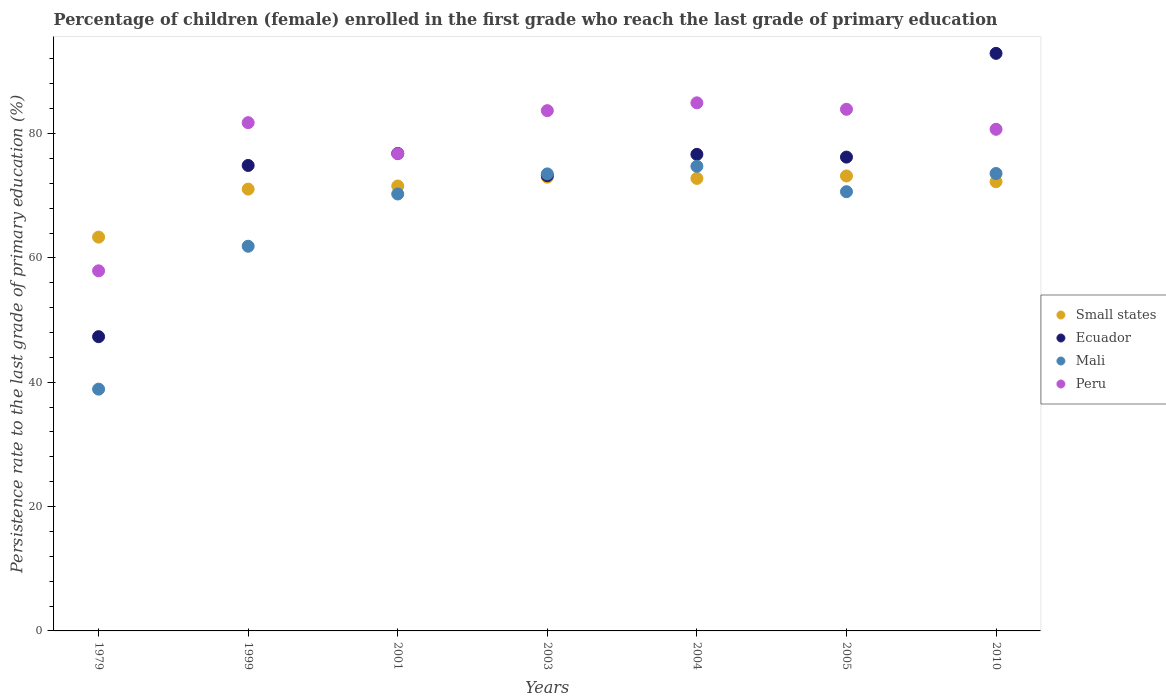Is the number of dotlines equal to the number of legend labels?
Keep it short and to the point. Yes. What is the persistence rate of children in Ecuador in 2003?
Your answer should be very brief. 73.23. Across all years, what is the maximum persistence rate of children in Ecuador?
Your response must be concise. 92.9. Across all years, what is the minimum persistence rate of children in Small states?
Give a very brief answer. 63.34. In which year was the persistence rate of children in Peru maximum?
Provide a short and direct response. 2004. In which year was the persistence rate of children in Ecuador minimum?
Your response must be concise. 1979. What is the total persistence rate of children in Mali in the graph?
Ensure brevity in your answer.  463.53. What is the difference between the persistence rate of children in Ecuador in 1979 and that in 2003?
Keep it short and to the point. -25.9. What is the difference between the persistence rate of children in Small states in 2003 and the persistence rate of children in Mali in 2010?
Offer a very short reply. -0.59. What is the average persistence rate of children in Mali per year?
Offer a very short reply. 66.22. In the year 2001, what is the difference between the persistence rate of children in Peru and persistence rate of children in Mali?
Provide a short and direct response. 6.48. What is the ratio of the persistence rate of children in Mali in 1999 to that in 2010?
Offer a terse response. 0.84. Is the persistence rate of children in Small states in 1979 less than that in 2004?
Keep it short and to the point. Yes. Is the difference between the persistence rate of children in Peru in 1979 and 2004 greater than the difference between the persistence rate of children in Mali in 1979 and 2004?
Your answer should be very brief. Yes. What is the difference between the highest and the second highest persistence rate of children in Mali?
Your response must be concise. 1.16. What is the difference between the highest and the lowest persistence rate of children in Ecuador?
Provide a short and direct response. 45.57. In how many years, is the persistence rate of children in Small states greater than the average persistence rate of children in Small states taken over all years?
Provide a succinct answer. 6. Is the sum of the persistence rate of children in Ecuador in 1999 and 2004 greater than the maximum persistence rate of children in Small states across all years?
Offer a very short reply. Yes. Is it the case that in every year, the sum of the persistence rate of children in Peru and persistence rate of children in Small states  is greater than the persistence rate of children in Mali?
Provide a short and direct response. Yes. Does the persistence rate of children in Small states monotonically increase over the years?
Keep it short and to the point. No. How many years are there in the graph?
Your answer should be compact. 7. What is the difference between two consecutive major ticks on the Y-axis?
Your response must be concise. 20. Does the graph contain any zero values?
Keep it short and to the point. No. Where does the legend appear in the graph?
Provide a succinct answer. Center right. How are the legend labels stacked?
Your answer should be compact. Vertical. What is the title of the graph?
Make the answer very short. Percentage of children (female) enrolled in the first grade who reach the last grade of primary education. Does "United Arab Emirates" appear as one of the legend labels in the graph?
Make the answer very short. No. What is the label or title of the X-axis?
Your answer should be compact. Years. What is the label or title of the Y-axis?
Offer a terse response. Persistence rate to the last grade of primary education (%). What is the Persistence rate to the last grade of primary education (%) of Small states in 1979?
Provide a short and direct response. 63.34. What is the Persistence rate to the last grade of primary education (%) in Ecuador in 1979?
Ensure brevity in your answer.  47.33. What is the Persistence rate to the last grade of primary education (%) in Mali in 1979?
Offer a very short reply. 38.89. What is the Persistence rate to the last grade of primary education (%) in Peru in 1979?
Make the answer very short. 57.92. What is the Persistence rate to the last grade of primary education (%) of Small states in 1999?
Make the answer very short. 71.07. What is the Persistence rate to the last grade of primary education (%) in Ecuador in 1999?
Ensure brevity in your answer.  74.87. What is the Persistence rate to the last grade of primary education (%) in Mali in 1999?
Provide a succinct answer. 61.88. What is the Persistence rate to the last grade of primary education (%) of Peru in 1999?
Your answer should be very brief. 81.75. What is the Persistence rate to the last grade of primary education (%) of Small states in 2001?
Keep it short and to the point. 71.57. What is the Persistence rate to the last grade of primary education (%) in Ecuador in 2001?
Give a very brief answer. 76.8. What is the Persistence rate to the last grade of primary education (%) of Mali in 2001?
Keep it short and to the point. 70.28. What is the Persistence rate to the last grade of primary education (%) in Peru in 2001?
Your answer should be compact. 76.77. What is the Persistence rate to the last grade of primary education (%) of Small states in 2003?
Make the answer very short. 72.99. What is the Persistence rate to the last grade of primary education (%) in Ecuador in 2003?
Offer a very short reply. 73.23. What is the Persistence rate to the last grade of primary education (%) of Mali in 2003?
Offer a very short reply. 73.51. What is the Persistence rate to the last grade of primary education (%) in Peru in 2003?
Ensure brevity in your answer.  83.69. What is the Persistence rate to the last grade of primary education (%) in Small states in 2004?
Give a very brief answer. 72.79. What is the Persistence rate to the last grade of primary education (%) of Ecuador in 2004?
Keep it short and to the point. 76.66. What is the Persistence rate to the last grade of primary education (%) in Mali in 2004?
Provide a succinct answer. 74.74. What is the Persistence rate to the last grade of primary education (%) in Peru in 2004?
Provide a short and direct response. 84.95. What is the Persistence rate to the last grade of primary education (%) in Small states in 2005?
Your response must be concise. 73.18. What is the Persistence rate to the last grade of primary education (%) of Ecuador in 2005?
Your answer should be very brief. 76.22. What is the Persistence rate to the last grade of primary education (%) of Mali in 2005?
Your answer should be compact. 70.65. What is the Persistence rate to the last grade of primary education (%) in Peru in 2005?
Make the answer very short. 83.91. What is the Persistence rate to the last grade of primary education (%) in Small states in 2010?
Provide a succinct answer. 72.26. What is the Persistence rate to the last grade of primary education (%) in Ecuador in 2010?
Make the answer very short. 92.9. What is the Persistence rate to the last grade of primary education (%) in Mali in 2010?
Provide a short and direct response. 73.58. What is the Persistence rate to the last grade of primary education (%) of Peru in 2010?
Keep it short and to the point. 80.69. Across all years, what is the maximum Persistence rate to the last grade of primary education (%) of Small states?
Keep it short and to the point. 73.18. Across all years, what is the maximum Persistence rate to the last grade of primary education (%) in Ecuador?
Ensure brevity in your answer.  92.9. Across all years, what is the maximum Persistence rate to the last grade of primary education (%) of Mali?
Your answer should be very brief. 74.74. Across all years, what is the maximum Persistence rate to the last grade of primary education (%) in Peru?
Provide a short and direct response. 84.95. Across all years, what is the minimum Persistence rate to the last grade of primary education (%) in Small states?
Ensure brevity in your answer.  63.34. Across all years, what is the minimum Persistence rate to the last grade of primary education (%) of Ecuador?
Your answer should be very brief. 47.33. Across all years, what is the minimum Persistence rate to the last grade of primary education (%) of Mali?
Make the answer very short. 38.89. Across all years, what is the minimum Persistence rate to the last grade of primary education (%) in Peru?
Your answer should be very brief. 57.92. What is the total Persistence rate to the last grade of primary education (%) in Small states in the graph?
Offer a terse response. 497.2. What is the total Persistence rate to the last grade of primary education (%) of Ecuador in the graph?
Offer a terse response. 518.01. What is the total Persistence rate to the last grade of primary education (%) in Mali in the graph?
Offer a terse response. 463.53. What is the total Persistence rate to the last grade of primary education (%) in Peru in the graph?
Make the answer very short. 549.67. What is the difference between the Persistence rate to the last grade of primary education (%) of Small states in 1979 and that in 1999?
Make the answer very short. -7.73. What is the difference between the Persistence rate to the last grade of primary education (%) in Ecuador in 1979 and that in 1999?
Ensure brevity in your answer.  -27.54. What is the difference between the Persistence rate to the last grade of primary education (%) of Mali in 1979 and that in 1999?
Your response must be concise. -22.99. What is the difference between the Persistence rate to the last grade of primary education (%) in Peru in 1979 and that in 1999?
Provide a short and direct response. -23.83. What is the difference between the Persistence rate to the last grade of primary education (%) in Small states in 1979 and that in 2001?
Offer a very short reply. -8.22. What is the difference between the Persistence rate to the last grade of primary education (%) in Ecuador in 1979 and that in 2001?
Offer a terse response. -29.47. What is the difference between the Persistence rate to the last grade of primary education (%) of Mali in 1979 and that in 2001?
Offer a very short reply. -31.39. What is the difference between the Persistence rate to the last grade of primary education (%) in Peru in 1979 and that in 2001?
Provide a short and direct response. -18.84. What is the difference between the Persistence rate to the last grade of primary education (%) in Small states in 1979 and that in 2003?
Offer a terse response. -9.64. What is the difference between the Persistence rate to the last grade of primary education (%) of Ecuador in 1979 and that in 2003?
Make the answer very short. -25.9. What is the difference between the Persistence rate to the last grade of primary education (%) of Mali in 1979 and that in 2003?
Ensure brevity in your answer.  -34.62. What is the difference between the Persistence rate to the last grade of primary education (%) in Peru in 1979 and that in 2003?
Give a very brief answer. -25.76. What is the difference between the Persistence rate to the last grade of primary education (%) in Small states in 1979 and that in 2004?
Provide a succinct answer. -9.44. What is the difference between the Persistence rate to the last grade of primary education (%) of Ecuador in 1979 and that in 2004?
Offer a terse response. -29.33. What is the difference between the Persistence rate to the last grade of primary education (%) of Mali in 1979 and that in 2004?
Your answer should be very brief. -35.85. What is the difference between the Persistence rate to the last grade of primary education (%) in Peru in 1979 and that in 2004?
Make the answer very short. -27.02. What is the difference between the Persistence rate to the last grade of primary education (%) of Small states in 1979 and that in 2005?
Provide a succinct answer. -9.84. What is the difference between the Persistence rate to the last grade of primary education (%) of Ecuador in 1979 and that in 2005?
Ensure brevity in your answer.  -28.88. What is the difference between the Persistence rate to the last grade of primary education (%) in Mali in 1979 and that in 2005?
Your response must be concise. -31.76. What is the difference between the Persistence rate to the last grade of primary education (%) in Peru in 1979 and that in 2005?
Your response must be concise. -25.98. What is the difference between the Persistence rate to the last grade of primary education (%) in Small states in 1979 and that in 2010?
Provide a short and direct response. -8.92. What is the difference between the Persistence rate to the last grade of primary education (%) of Ecuador in 1979 and that in 2010?
Give a very brief answer. -45.57. What is the difference between the Persistence rate to the last grade of primary education (%) in Mali in 1979 and that in 2010?
Your answer should be compact. -34.69. What is the difference between the Persistence rate to the last grade of primary education (%) in Peru in 1979 and that in 2010?
Your answer should be compact. -22.76. What is the difference between the Persistence rate to the last grade of primary education (%) in Small states in 1999 and that in 2001?
Provide a short and direct response. -0.5. What is the difference between the Persistence rate to the last grade of primary education (%) of Ecuador in 1999 and that in 2001?
Keep it short and to the point. -1.93. What is the difference between the Persistence rate to the last grade of primary education (%) of Mali in 1999 and that in 2001?
Make the answer very short. -8.41. What is the difference between the Persistence rate to the last grade of primary education (%) in Peru in 1999 and that in 2001?
Your answer should be compact. 4.99. What is the difference between the Persistence rate to the last grade of primary education (%) in Small states in 1999 and that in 2003?
Your answer should be very brief. -1.92. What is the difference between the Persistence rate to the last grade of primary education (%) of Ecuador in 1999 and that in 2003?
Provide a short and direct response. 1.64. What is the difference between the Persistence rate to the last grade of primary education (%) of Mali in 1999 and that in 2003?
Your response must be concise. -11.64. What is the difference between the Persistence rate to the last grade of primary education (%) in Peru in 1999 and that in 2003?
Your answer should be compact. -1.93. What is the difference between the Persistence rate to the last grade of primary education (%) of Small states in 1999 and that in 2004?
Provide a short and direct response. -1.72. What is the difference between the Persistence rate to the last grade of primary education (%) of Ecuador in 1999 and that in 2004?
Keep it short and to the point. -1.79. What is the difference between the Persistence rate to the last grade of primary education (%) of Mali in 1999 and that in 2004?
Provide a short and direct response. -12.86. What is the difference between the Persistence rate to the last grade of primary education (%) of Peru in 1999 and that in 2004?
Offer a terse response. -3.19. What is the difference between the Persistence rate to the last grade of primary education (%) of Small states in 1999 and that in 2005?
Give a very brief answer. -2.11. What is the difference between the Persistence rate to the last grade of primary education (%) of Ecuador in 1999 and that in 2005?
Offer a terse response. -1.34. What is the difference between the Persistence rate to the last grade of primary education (%) in Mali in 1999 and that in 2005?
Ensure brevity in your answer.  -8.77. What is the difference between the Persistence rate to the last grade of primary education (%) of Peru in 1999 and that in 2005?
Your answer should be very brief. -2.15. What is the difference between the Persistence rate to the last grade of primary education (%) of Small states in 1999 and that in 2010?
Offer a very short reply. -1.19. What is the difference between the Persistence rate to the last grade of primary education (%) of Ecuador in 1999 and that in 2010?
Your answer should be very brief. -18.03. What is the difference between the Persistence rate to the last grade of primary education (%) of Mali in 1999 and that in 2010?
Provide a succinct answer. -11.7. What is the difference between the Persistence rate to the last grade of primary education (%) of Peru in 1999 and that in 2010?
Make the answer very short. 1.07. What is the difference between the Persistence rate to the last grade of primary education (%) of Small states in 2001 and that in 2003?
Make the answer very short. -1.42. What is the difference between the Persistence rate to the last grade of primary education (%) of Ecuador in 2001 and that in 2003?
Provide a short and direct response. 3.57. What is the difference between the Persistence rate to the last grade of primary education (%) of Mali in 2001 and that in 2003?
Your answer should be compact. -3.23. What is the difference between the Persistence rate to the last grade of primary education (%) in Peru in 2001 and that in 2003?
Provide a short and direct response. -6.92. What is the difference between the Persistence rate to the last grade of primary education (%) of Small states in 2001 and that in 2004?
Keep it short and to the point. -1.22. What is the difference between the Persistence rate to the last grade of primary education (%) of Ecuador in 2001 and that in 2004?
Your answer should be compact. 0.15. What is the difference between the Persistence rate to the last grade of primary education (%) in Mali in 2001 and that in 2004?
Your answer should be very brief. -4.46. What is the difference between the Persistence rate to the last grade of primary education (%) in Peru in 2001 and that in 2004?
Make the answer very short. -8.18. What is the difference between the Persistence rate to the last grade of primary education (%) in Small states in 2001 and that in 2005?
Offer a very short reply. -1.62. What is the difference between the Persistence rate to the last grade of primary education (%) of Ecuador in 2001 and that in 2005?
Offer a very short reply. 0.59. What is the difference between the Persistence rate to the last grade of primary education (%) of Mali in 2001 and that in 2005?
Provide a succinct answer. -0.37. What is the difference between the Persistence rate to the last grade of primary education (%) of Peru in 2001 and that in 2005?
Ensure brevity in your answer.  -7.14. What is the difference between the Persistence rate to the last grade of primary education (%) of Small states in 2001 and that in 2010?
Provide a short and direct response. -0.7. What is the difference between the Persistence rate to the last grade of primary education (%) in Ecuador in 2001 and that in 2010?
Make the answer very short. -16.1. What is the difference between the Persistence rate to the last grade of primary education (%) in Mali in 2001 and that in 2010?
Offer a terse response. -3.3. What is the difference between the Persistence rate to the last grade of primary education (%) of Peru in 2001 and that in 2010?
Make the answer very short. -3.92. What is the difference between the Persistence rate to the last grade of primary education (%) of Small states in 2003 and that in 2004?
Keep it short and to the point. 0.2. What is the difference between the Persistence rate to the last grade of primary education (%) of Ecuador in 2003 and that in 2004?
Keep it short and to the point. -3.42. What is the difference between the Persistence rate to the last grade of primary education (%) in Mali in 2003 and that in 2004?
Give a very brief answer. -1.22. What is the difference between the Persistence rate to the last grade of primary education (%) in Peru in 2003 and that in 2004?
Offer a terse response. -1.26. What is the difference between the Persistence rate to the last grade of primary education (%) of Small states in 2003 and that in 2005?
Your answer should be compact. -0.19. What is the difference between the Persistence rate to the last grade of primary education (%) of Ecuador in 2003 and that in 2005?
Provide a succinct answer. -2.98. What is the difference between the Persistence rate to the last grade of primary education (%) of Mali in 2003 and that in 2005?
Your answer should be compact. 2.86. What is the difference between the Persistence rate to the last grade of primary education (%) in Peru in 2003 and that in 2005?
Ensure brevity in your answer.  -0.22. What is the difference between the Persistence rate to the last grade of primary education (%) in Small states in 2003 and that in 2010?
Make the answer very short. 0.73. What is the difference between the Persistence rate to the last grade of primary education (%) of Ecuador in 2003 and that in 2010?
Make the answer very short. -19.67. What is the difference between the Persistence rate to the last grade of primary education (%) in Mali in 2003 and that in 2010?
Ensure brevity in your answer.  -0.06. What is the difference between the Persistence rate to the last grade of primary education (%) of Peru in 2003 and that in 2010?
Offer a terse response. 3. What is the difference between the Persistence rate to the last grade of primary education (%) in Small states in 2004 and that in 2005?
Give a very brief answer. -0.4. What is the difference between the Persistence rate to the last grade of primary education (%) of Ecuador in 2004 and that in 2005?
Your answer should be compact. 0.44. What is the difference between the Persistence rate to the last grade of primary education (%) in Mali in 2004 and that in 2005?
Keep it short and to the point. 4.09. What is the difference between the Persistence rate to the last grade of primary education (%) of Peru in 2004 and that in 2005?
Provide a short and direct response. 1.04. What is the difference between the Persistence rate to the last grade of primary education (%) in Small states in 2004 and that in 2010?
Give a very brief answer. 0.52. What is the difference between the Persistence rate to the last grade of primary education (%) in Ecuador in 2004 and that in 2010?
Offer a very short reply. -16.25. What is the difference between the Persistence rate to the last grade of primary education (%) in Mali in 2004 and that in 2010?
Your answer should be compact. 1.16. What is the difference between the Persistence rate to the last grade of primary education (%) of Peru in 2004 and that in 2010?
Keep it short and to the point. 4.26. What is the difference between the Persistence rate to the last grade of primary education (%) in Small states in 2005 and that in 2010?
Provide a succinct answer. 0.92. What is the difference between the Persistence rate to the last grade of primary education (%) of Ecuador in 2005 and that in 2010?
Offer a terse response. -16.69. What is the difference between the Persistence rate to the last grade of primary education (%) in Mali in 2005 and that in 2010?
Offer a terse response. -2.93. What is the difference between the Persistence rate to the last grade of primary education (%) in Peru in 2005 and that in 2010?
Your response must be concise. 3.22. What is the difference between the Persistence rate to the last grade of primary education (%) in Small states in 1979 and the Persistence rate to the last grade of primary education (%) in Ecuador in 1999?
Make the answer very short. -11.53. What is the difference between the Persistence rate to the last grade of primary education (%) of Small states in 1979 and the Persistence rate to the last grade of primary education (%) of Mali in 1999?
Make the answer very short. 1.47. What is the difference between the Persistence rate to the last grade of primary education (%) in Small states in 1979 and the Persistence rate to the last grade of primary education (%) in Peru in 1999?
Your answer should be very brief. -18.41. What is the difference between the Persistence rate to the last grade of primary education (%) in Ecuador in 1979 and the Persistence rate to the last grade of primary education (%) in Mali in 1999?
Your answer should be compact. -14.54. What is the difference between the Persistence rate to the last grade of primary education (%) in Ecuador in 1979 and the Persistence rate to the last grade of primary education (%) in Peru in 1999?
Provide a succinct answer. -34.42. What is the difference between the Persistence rate to the last grade of primary education (%) in Mali in 1979 and the Persistence rate to the last grade of primary education (%) in Peru in 1999?
Keep it short and to the point. -42.86. What is the difference between the Persistence rate to the last grade of primary education (%) of Small states in 1979 and the Persistence rate to the last grade of primary education (%) of Ecuador in 2001?
Offer a very short reply. -13.46. What is the difference between the Persistence rate to the last grade of primary education (%) of Small states in 1979 and the Persistence rate to the last grade of primary education (%) of Mali in 2001?
Provide a succinct answer. -6.94. What is the difference between the Persistence rate to the last grade of primary education (%) in Small states in 1979 and the Persistence rate to the last grade of primary education (%) in Peru in 2001?
Keep it short and to the point. -13.42. What is the difference between the Persistence rate to the last grade of primary education (%) in Ecuador in 1979 and the Persistence rate to the last grade of primary education (%) in Mali in 2001?
Provide a succinct answer. -22.95. What is the difference between the Persistence rate to the last grade of primary education (%) in Ecuador in 1979 and the Persistence rate to the last grade of primary education (%) in Peru in 2001?
Your response must be concise. -29.43. What is the difference between the Persistence rate to the last grade of primary education (%) in Mali in 1979 and the Persistence rate to the last grade of primary education (%) in Peru in 2001?
Ensure brevity in your answer.  -37.88. What is the difference between the Persistence rate to the last grade of primary education (%) in Small states in 1979 and the Persistence rate to the last grade of primary education (%) in Ecuador in 2003?
Your answer should be compact. -9.89. What is the difference between the Persistence rate to the last grade of primary education (%) in Small states in 1979 and the Persistence rate to the last grade of primary education (%) in Mali in 2003?
Your answer should be very brief. -10.17. What is the difference between the Persistence rate to the last grade of primary education (%) of Small states in 1979 and the Persistence rate to the last grade of primary education (%) of Peru in 2003?
Offer a terse response. -20.35. What is the difference between the Persistence rate to the last grade of primary education (%) of Ecuador in 1979 and the Persistence rate to the last grade of primary education (%) of Mali in 2003?
Offer a very short reply. -26.18. What is the difference between the Persistence rate to the last grade of primary education (%) of Ecuador in 1979 and the Persistence rate to the last grade of primary education (%) of Peru in 2003?
Your response must be concise. -36.36. What is the difference between the Persistence rate to the last grade of primary education (%) of Mali in 1979 and the Persistence rate to the last grade of primary education (%) of Peru in 2003?
Keep it short and to the point. -44.8. What is the difference between the Persistence rate to the last grade of primary education (%) of Small states in 1979 and the Persistence rate to the last grade of primary education (%) of Ecuador in 2004?
Make the answer very short. -13.31. What is the difference between the Persistence rate to the last grade of primary education (%) in Small states in 1979 and the Persistence rate to the last grade of primary education (%) in Mali in 2004?
Make the answer very short. -11.4. What is the difference between the Persistence rate to the last grade of primary education (%) in Small states in 1979 and the Persistence rate to the last grade of primary education (%) in Peru in 2004?
Give a very brief answer. -21.6. What is the difference between the Persistence rate to the last grade of primary education (%) of Ecuador in 1979 and the Persistence rate to the last grade of primary education (%) of Mali in 2004?
Keep it short and to the point. -27.41. What is the difference between the Persistence rate to the last grade of primary education (%) of Ecuador in 1979 and the Persistence rate to the last grade of primary education (%) of Peru in 2004?
Ensure brevity in your answer.  -37.61. What is the difference between the Persistence rate to the last grade of primary education (%) of Mali in 1979 and the Persistence rate to the last grade of primary education (%) of Peru in 2004?
Your answer should be compact. -46.05. What is the difference between the Persistence rate to the last grade of primary education (%) in Small states in 1979 and the Persistence rate to the last grade of primary education (%) in Ecuador in 2005?
Make the answer very short. -12.87. What is the difference between the Persistence rate to the last grade of primary education (%) in Small states in 1979 and the Persistence rate to the last grade of primary education (%) in Mali in 2005?
Offer a terse response. -7.31. What is the difference between the Persistence rate to the last grade of primary education (%) of Small states in 1979 and the Persistence rate to the last grade of primary education (%) of Peru in 2005?
Make the answer very short. -20.56. What is the difference between the Persistence rate to the last grade of primary education (%) in Ecuador in 1979 and the Persistence rate to the last grade of primary education (%) in Mali in 2005?
Provide a short and direct response. -23.32. What is the difference between the Persistence rate to the last grade of primary education (%) in Ecuador in 1979 and the Persistence rate to the last grade of primary education (%) in Peru in 2005?
Provide a short and direct response. -36.57. What is the difference between the Persistence rate to the last grade of primary education (%) in Mali in 1979 and the Persistence rate to the last grade of primary education (%) in Peru in 2005?
Your answer should be very brief. -45.02. What is the difference between the Persistence rate to the last grade of primary education (%) in Small states in 1979 and the Persistence rate to the last grade of primary education (%) in Ecuador in 2010?
Provide a succinct answer. -29.56. What is the difference between the Persistence rate to the last grade of primary education (%) in Small states in 1979 and the Persistence rate to the last grade of primary education (%) in Mali in 2010?
Your response must be concise. -10.24. What is the difference between the Persistence rate to the last grade of primary education (%) of Small states in 1979 and the Persistence rate to the last grade of primary education (%) of Peru in 2010?
Give a very brief answer. -17.34. What is the difference between the Persistence rate to the last grade of primary education (%) of Ecuador in 1979 and the Persistence rate to the last grade of primary education (%) of Mali in 2010?
Your response must be concise. -26.25. What is the difference between the Persistence rate to the last grade of primary education (%) of Ecuador in 1979 and the Persistence rate to the last grade of primary education (%) of Peru in 2010?
Give a very brief answer. -33.36. What is the difference between the Persistence rate to the last grade of primary education (%) of Mali in 1979 and the Persistence rate to the last grade of primary education (%) of Peru in 2010?
Ensure brevity in your answer.  -41.8. What is the difference between the Persistence rate to the last grade of primary education (%) in Small states in 1999 and the Persistence rate to the last grade of primary education (%) in Ecuador in 2001?
Your answer should be very brief. -5.73. What is the difference between the Persistence rate to the last grade of primary education (%) in Small states in 1999 and the Persistence rate to the last grade of primary education (%) in Mali in 2001?
Keep it short and to the point. 0.79. What is the difference between the Persistence rate to the last grade of primary education (%) in Small states in 1999 and the Persistence rate to the last grade of primary education (%) in Peru in 2001?
Your answer should be very brief. -5.7. What is the difference between the Persistence rate to the last grade of primary education (%) of Ecuador in 1999 and the Persistence rate to the last grade of primary education (%) of Mali in 2001?
Make the answer very short. 4.59. What is the difference between the Persistence rate to the last grade of primary education (%) of Ecuador in 1999 and the Persistence rate to the last grade of primary education (%) of Peru in 2001?
Your answer should be compact. -1.89. What is the difference between the Persistence rate to the last grade of primary education (%) of Mali in 1999 and the Persistence rate to the last grade of primary education (%) of Peru in 2001?
Your answer should be very brief. -14.89. What is the difference between the Persistence rate to the last grade of primary education (%) of Small states in 1999 and the Persistence rate to the last grade of primary education (%) of Ecuador in 2003?
Your answer should be compact. -2.16. What is the difference between the Persistence rate to the last grade of primary education (%) of Small states in 1999 and the Persistence rate to the last grade of primary education (%) of Mali in 2003?
Offer a very short reply. -2.44. What is the difference between the Persistence rate to the last grade of primary education (%) in Small states in 1999 and the Persistence rate to the last grade of primary education (%) in Peru in 2003?
Provide a succinct answer. -12.62. What is the difference between the Persistence rate to the last grade of primary education (%) of Ecuador in 1999 and the Persistence rate to the last grade of primary education (%) of Mali in 2003?
Provide a succinct answer. 1.36. What is the difference between the Persistence rate to the last grade of primary education (%) of Ecuador in 1999 and the Persistence rate to the last grade of primary education (%) of Peru in 2003?
Your answer should be compact. -8.82. What is the difference between the Persistence rate to the last grade of primary education (%) of Mali in 1999 and the Persistence rate to the last grade of primary education (%) of Peru in 2003?
Offer a terse response. -21.81. What is the difference between the Persistence rate to the last grade of primary education (%) in Small states in 1999 and the Persistence rate to the last grade of primary education (%) in Ecuador in 2004?
Provide a succinct answer. -5.59. What is the difference between the Persistence rate to the last grade of primary education (%) in Small states in 1999 and the Persistence rate to the last grade of primary education (%) in Mali in 2004?
Give a very brief answer. -3.67. What is the difference between the Persistence rate to the last grade of primary education (%) of Small states in 1999 and the Persistence rate to the last grade of primary education (%) of Peru in 2004?
Keep it short and to the point. -13.87. What is the difference between the Persistence rate to the last grade of primary education (%) of Ecuador in 1999 and the Persistence rate to the last grade of primary education (%) of Mali in 2004?
Ensure brevity in your answer.  0.13. What is the difference between the Persistence rate to the last grade of primary education (%) of Ecuador in 1999 and the Persistence rate to the last grade of primary education (%) of Peru in 2004?
Make the answer very short. -10.07. What is the difference between the Persistence rate to the last grade of primary education (%) in Mali in 1999 and the Persistence rate to the last grade of primary education (%) in Peru in 2004?
Ensure brevity in your answer.  -23.07. What is the difference between the Persistence rate to the last grade of primary education (%) in Small states in 1999 and the Persistence rate to the last grade of primary education (%) in Ecuador in 2005?
Ensure brevity in your answer.  -5.15. What is the difference between the Persistence rate to the last grade of primary education (%) in Small states in 1999 and the Persistence rate to the last grade of primary education (%) in Mali in 2005?
Ensure brevity in your answer.  0.42. What is the difference between the Persistence rate to the last grade of primary education (%) of Small states in 1999 and the Persistence rate to the last grade of primary education (%) of Peru in 2005?
Offer a terse response. -12.84. What is the difference between the Persistence rate to the last grade of primary education (%) in Ecuador in 1999 and the Persistence rate to the last grade of primary education (%) in Mali in 2005?
Make the answer very short. 4.22. What is the difference between the Persistence rate to the last grade of primary education (%) in Ecuador in 1999 and the Persistence rate to the last grade of primary education (%) in Peru in 2005?
Keep it short and to the point. -9.04. What is the difference between the Persistence rate to the last grade of primary education (%) in Mali in 1999 and the Persistence rate to the last grade of primary education (%) in Peru in 2005?
Give a very brief answer. -22.03. What is the difference between the Persistence rate to the last grade of primary education (%) of Small states in 1999 and the Persistence rate to the last grade of primary education (%) of Ecuador in 2010?
Ensure brevity in your answer.  -21.83. What is the difference between the Persistence rate to the last grade of primary education (%) in Small states in 1999 and the Persistence rate to the last grade of primary education (%) in Mali in 2010?
Ensure brevity in your answer.  -2.51. What is the difference between the Persistence rate to the last grade of primary education (%) of Small states in 1999 and the Persistence rate to the last grade of primary education (%) of Peru in 2010?
Your response must be concise. -9.62. What is the difference between the Persistence rate to the last grade of primary education (%) of Ecuador in 1999 and the Persistence rate to the last grade of primary education (%) of Mali in 2010?
Provide a short and direct response. 1.29. What is the difference between the Persistence rate to the last grade of primary education (%) of Ecuador in 1999 and the Persistence rate to the last grade of primary education (%) of Peru in 2010?
Provide a short and direct response. -5.82. What is the difference between the Persistence rate to the last grade of primary education (%) in Mali in 1999 and the Persistence rate to the last grade of primary education (%) in Peru in 2010?
Offer a very short reply. -18.81. What is the difference between the Persistence rate to the last grade of primary education (%) in Small states in 2001 and the Persistence rate to the last grade of primary education (%) in Ecuador in 2003?
Your response must be concise. -1.67. What is the difference between the Persistence rate to the last grade of primary education (%) of Small states in 2001 and the Persistence rate to the last grade of primary education (%) of Mali in 2003?
Your answer should be very brief. -1.95. What is the difference between the Persistence rate to the last grade of primary education (%) of Small states in 2001 and the Persistence rate to the last grade of primary education (%) of Peru in 2003?
Keep it short and to the point. -12.12. What is the difference between the Persistence rate to the last grade of primary education (%) in Ecuador in 2001 and the Persistence rate to the last grade of primary education (%) in Mali in 2003?
Ensure brevity in your answer.  3.29. What is the difference between the Persistence rate to the last grade of primary education (%) in Ecuador in 2001 and the Persistence rate to the last grade of primary education (%) in Peru in 2003?
Make the answer very short. -6.89. What is the difference between the Persistence rate to the last grade of primary education (%) in Mali in 2001 and the Persistence rate to the last grade of primary education (%) in Peru in 2003?
Make the answer very short. -13.41. What is the difference between the Persistence rate to the last grade of primary education (%) of Small states in 2001 and the Persistence rate to the last grade of primary education (%) of Ecuador in 2004?
Your response must be concise. -5.09. What is the difference between the Persistence rate to the last grade of primary education (%) in Small states in 2001 and the Persistence rate to the last grade of primary education (%) in Mali in 2004?
Make the answer very short. -3.17. What is the difference between the Persistence rate to the last grade of primary education (%) of Small states in 2001 and the Persistence rate to the last grade of primary education (%) of Peru in 2004?
Make the answer very short. -13.38. What is the difference between the Persistence rate to the last grade of primary education (%) in Ecuador in 2001 and the Persistence rate to the last grade of primary education (%) in Mali in 2004?
Your response must be concise. 2.06. What is the difference between the Persistence rate to the last grade of primary education (%) in Ecuador in 2001 and the Persistence rate to the last grade of primary education (%) in Peru in 2004?
Keep it short and to the point. -8.14. What is the difference between the Persistence rate to the last grade of primary education (%) in Mali in 2001 and the Persistence rate to the last grade of primary education (%) in Peru in 2004?
Your answer should be compact. -14.66. What is the difference between the Persistence rate to the last grade of primary education (%) in Small states in 2001 and the Persistence rate to the last grade of primary education (%) in Ecuador in 2005?
Your response must be concise. -4.65. What is the difference between the Persistence rate to the last grade of primary education (%) of Small states in 2001 and the Persistence rate to the last grade of primary education (%) of Mali in 2005?
Your response must be concise. 0.92. What is the difference between the Persistence rate to the last grade of primary education (%) of Small states in 2001 and the Persistence rate to the last grade of primary education (%) of Peru in 2005?
Your response must be concise. -12.34. What is the difference between the Persistence rate to the last grade of primary education (%) of Ecuador in 2001 and the Persistence rate to the last grade of primary education (%) of Mali in 2005?
Give a very brief answer. 6.15. What is the difference between the Persistence rate to the last grade of primary education (%) in Ecuador in 2001 and the Persistence rate to the last grade of primary education (%) in Peru in 2005?
Keep it short and to the point. -7.1. What is the difference between the Persistence rate to the last grade of primary education (%) of Mali in 2001 and the Persistence rate to the last grade of primary education (%) of Peru in 2005?
Keep it short and to the point. -13.62. What is the difference between the Persistence rate to the last grade of primary education (%) in Small states in 2001 and the Persistence rate to the last grade of primary education (%) in Ecuador in 2010?
Ensure brevity in your answer.  -21.34. What is the difference between the Persistence rate to the last grade of primary education (%) of Small states in 2001 and the Persistence rate to the last grade of primary education (%) of Mali in 2010?
Make the answer very short. -2.01. What is the difference between the Persistence rate to the last grade of primary education (%) of Small states in 2001 and the Persistence rate to the last grade of primary education (%) of Peru in 2010?
Offer a terse response. -9.12. What is the difference between the Persistence rate to the last grade of primary education (%) in Ecuador in 2001 and the Persistence rate to the last grade of primary education (%) in Mali in 2010?
Give a very brief answer. 3.22. What is the difference between the Persistence rate to the last grade of primary education (%) in Ecuador in 2001 and the Persistence rate to the last grade of primary education (%) in Peru in 2010?
Provide a succinct answer. -3.89. What is the difference between the Persistence rate to the last grade of primary education (%) in Mali in 2001 and the Persistence rate to the last grade of primary education (%) in Peru in 2010?
Provide a short and direct response. -10.41. What is the difference between the Persistence rate to the last grade of primary education (%) in Small states in 2003 and the Persistence rate to the last grade of primary education (%) in Ecuador in 2004?
Your answer should be compact. -3.67. What is the difference between the Persistence rate to the last grade of primary education (%) of Small states in 2003 and the Persistence rate to the last grade of primary education (%) of Mali in 2004?
Offer a terse response. -1.75. What is the difference between the Persistence rate to the last grade of primary education (%) in Small states in 2003 and the Persistence rate to the last grade of primary education (%) in Peru in 2004?
Give a very brief answer. -11.96. What is the difference between the Persistence rate to the last grade of primary education (%) in Ecuador in 2003 and the Persistence rate to the last grade of primary education (%) in Mali in 2004?
Ensure brevity in your answer.  -1.51. What is the difference between the Persistence rate to the last grade of primary education (%) of Ecuador in 2003 and the Persistence rate to the last grade of primary education (%) of Peru in 2004?
Make the answer very short. -11.71. What is the difference between the Persistence rate to the last grade of primary education (%) of Mali in 2003 and the Persistence rate to the last grade of primary education (%) of Peru in 2004?
Keep it short and to the point. -11.43. What is the difference between the Persistence rate to the last grade of primary education (%) in Small states in 2003 and the Persistence rate to the last grade of primary education (%) in Ecuador in 2005?
Keep it short and to the point. -3.23. What is the difference between the Persistence rate to the last grade of primary education (%) of Small states in 2003 and the Persistence rate to the last grade of primary education (%) of Mali in 2005?
Make the answer very short. 2.34. What is the difference between the Persistence rate to the last grade of primary education (%) in Small states in 2003 and the Persistence rate to the last grade of primary education (%) in Peru in 2005?
Provide a short and direct response. -10.92. What is the difference between the Persistence rate to the last grade of primary education (%) in Ecuador in 2003 and the Persistence rate to the last grade of primary education (%) in Mali in 2005?
Your answer should be very brief. 2.58. What is the difference between the Persistence rate to the last grade of primary education (%) in Ecuador in 2003 and the Persistence rate to the last grade of primary education (%) in Peru in 2005?
Provide a succinct answer. -10.67. What is the difference between the Persistence rate to the last grade of primary education (%) in Mali in 2003 and the Persistence rate to the last grade of primary education (%) in Peru in 2005?
Make the answer very short. -10.39. What is the difference between the Persistence rate to the last grade of primary education (%) of Small states in 2003 and the Persistence rate to the last grade of primary education (%) of Ecuador in 2010?
Make the answer very short. -19.91. What is the difference between the Persistence rate to the last grade of primary education (%) of Small states in 2003 and the Persistence rate to the last grade of primary education (%) of Mali in 2010?
Provide a short and direct response. -0.59. What is the difference between the Persistence rate to the last grade of primary education (%) of Ecuador in 2003 and the Persistence rate to the last grade of primary education (%) of Mali in 2010?
Offer a terse response. -0.35. What is the difference between the Persistence rate to the last grade of primary education (%) of Ecuador in 2003 and the Persistence rate to the last grade of primary education (%) of Peru in 2010?
Keep it short and to the point. -7.46. What is the difference between the Persistence rate to the last grade of primary education (%) of Mali in 2003 and the Persistence rate to the last grade of primary education (%) of Peru in 2010?
Offer a very short reply. -7.17. What is the difference between the Persistence rate to the last grade of primary education (%) of Small states in 2004 and the Persistence rate to the last grade of primary education (%) of Ecuador in 2005?
Give a very brief answer. -3.43. What is the difference between the Persistence rate to the last grade of primary education (%) of Small states in 2004 and the Persistence rate to the last grade of primary education (%) of Mali in 2005?
Give a very brief answer. 2.14. What is the difference between the Persistence rate to the last grade of primary education (%) of Small states in 2004 and the Persistence rate to the last grade of primary education (%) of Peru in 2005?
Keep it short and to the point. -11.12. What is the difference between the Persistence rate to the last grade of primary education (%) in Ecuador in 2004 and the Persistence rate to the last grade of primary education (%) in Mali in 2005?
Your answer should be compact. 6.01. What is the difference between the Persistence rate to the last grade of primary education (%) of Ecuador in 2004 and the Persistence rate to the last grade of primary education (%) of Peru in 2005?
Give a very brief answer. -7.25. What is the difference between the Persistence rate to the last grade of primary education (%) in Mali in 2004 and the Persistence rate to the last grade of primary education (%) in Peru in 2005?
Keep it short and to the point. -9.17. What is the difference between the Persistence rate to the last grade of primary education (%) in Small states in 2004 and the Persistence rate to the last grade of primary education (%) in Ecuador in 2010?
Offer a terse response. -20.12. What is the difference between the Persistence rate to the last grade of primary education (%) of Small states in 2004 and the Persistence rate to the last grade of primary education (%) of Mali in 2010?
Your answer should be very brief. -0.79. What is the difference between the Persistence rate to the last grade of primary education (%) of Small states in 2004 and the Persistence rate to the last grade of primary education (%) of Peru in 2010?
Ensure brevity in your answer.  -7.9. What is the difference between the Persistence rate to the last grade of primary education (%) of Ecuador in 2004 and the Persistence rate to the last grade of primary education (%) of Mali in 2010?
Your answer should be very brief. 3.08. What is the difference between the Persistence rate to the last grade of primary education (%) of Ecuador in 2004 and the Persistence rate to the last grade of primary education (%) of Peru in 2010?
Your response must be concise. -4.03. What is the difference between the Persistence rate to the last grade of primary education (%) in Mali in 2004 and the Persistence rate to the last grade of primary education (%) in Peru in 2010?
Your response must be concise. -5.95. What is the difference between the Persistence rate to the last grade of primary education (%) of Small states in 2005 and the Persistence rate to the last grade of primary education (%) of Ecuador in 2010?
Provide a succinct answer. -19.72. What is the difference between the Persistence rate to the last grade of primary education (%) of Small states in 2005 and the Persistence rate to the last grade of primary education (%) of Mali in 2010?
Provide a succinct answer. -0.4. What is the difference between the Persistence rate to the last grade of primary education (%) of Small states in 2005 and the Persistence rate to the last grade of primary education (%) of Peru in 2010?
Your answer should be compact. -7.51. What is the difference between the Persistence rate to the last grade of primary education (%) of Ecuador in 2005 and the Persistence rate to the last grade of primary education (%) of Mali in 2010?
Your answer should be compact. 2.64. What is the difference between the Persistence rate to the last grade of primary education (%) of Ecuador in 2005 and the Persistence rate to the last grade of primary education (%) of Peru in 2010?
Ensure brevity in your answer.  -4.47. What is the difference between the Persistence rate to the last grade of primary education (%) of Mali in 2005 and the Persistence rate to the last grade of primary education (%) of Peru in 2010?
Provide a succinct answer. -10.04. What is the average Persistence rate to the last grade of primary education (%) in Small states per year?
Ensure brevity in your answer.  71.03. What is the average Persistence rate to the last grade of primary education (%) of Ecuador per year?
Keep it short and to the point. 74. What is the average Persistence rate to the last grade of primary education (%) in Mali per year?
Offer a terse response. 66.22. What is the average Persistence rate to the last grade of primary education (%) in Peru per year?
Keep it short and to the point. 78.52. In the year 1979, what is the difference between the Persistence rate to the last grade of primary education (%) in Small states and Persistence rate to the last grade of primary education (%) in Ecuador?
Ensure brevity in your answer.  16.01. In the year 1979, what is the difference between the Persistence rate to the last grade of primary education (%) in Small states and Persistence rate to the last grade of primary education (%) in Mali?
Your answer should be compact. 24.45. In the year 1979, what is the difference between the Persistence rate to the last grade of primary education (%) in Small states and Persistence rate to the last grade of primary education (%) in Peru?
Ensure brevity in your answer.  5.42. In the year 1979, what is the difference between the Persistence rate to the last grade of primary education (%) of Ecuador and Persistence rate to the last grade of primary education (%) of Mali?
Offer a terse response. 8.44. In the year 1979, what is the difference between the Persistence rate to the last grade of primary education (%) in Ecuador and Persistence rate to the last grade of primary education (%) in Peru?
Keep it short and to the point. -10.59. In the year 1979, what is the difference between the Persistence rate to the last grade of primary education (%) of Mali and Persistence rate to the last grade of primary education (%) of Peru?
Offer a terse response. -19.03. In the year 1999, what is the difference between the Persistence rate to the last grade of primary education (%) in Small states and Persistence rate to the last grade of primary education (%) in Ecuador?
Your answer should be very brief. -3.8. In the year 1999, what is the difference between the Persistence rate to the last grade of primary education (%) of Small states and Persistence rate to the last grade of primary education (%) of Mali?
Your answer should be very brief. 9.19. In the year 1999, what is the difference between the Persistence rate to the last grade of primary education (%) in Small states and Persistence rate to the last grade of primary education (%) in Peru?
Ensure brevity in your answer.  -10.68. In the year 1999, what is the difference between the Persistence rate to the last grade of primary education (%) in Ecuador and Persistence rate to the last grade of primary education (%) in Mali?
Offer a very short reply. 13. In the year 1999, what is the difference between the Persistence rate to the last grade of primary education (%) of Ecuador and Persistence rate to the last grade of primary education (%) of Peru?
Provide a succinct answer. -6.88. In the year 1999, what is the difference between the Persistence rate to the last grade of primary education (%) of Mali and Persistence rate to the last grade of primary education (%) of Peru?
Offer a very short reply. -19.88. In the year 2001, what is the difference between the Persistence rate to the last grade of primary education (%) of Small states and Persistence rate to the last grade of primary education (%) of Ecuador?
Offer a very short reply. -5.24. In the year 2001, what is the difference between the Persistence rate to the last grade of primary education (%) of Small states and Persistence rate to the last grade of primary education (%) of Mali?
Provide a short and direct response. 1.28. In the year 2001, what is the difference between the Persistence rate to the last grade of primary education (%) in Small states and Persistence rate to the last grade of primary education (%) in Peru?
Make the answer very short. -5.2. In the year 2001, what is the difference between the Persistence rate to the last grade of primary education (%) of Ecuador and Persistence rate to the last grade of primary education (%) of Mali?
Provide a short and direct response. 6.52. In the year 2001, what is the difference between the Persistence rate to the last grade of primary education (%) in Ecuador and Persistence rate to the last grade of primary education (%) in Peru?
Ensure brevity in your answer.  0.04. In the year 2001, what is the difference between the Persistence rate to the last grade of primary education (%) of Mali and Persistence rate to the last grade of primary education (%) of Peru?
Keep it short and to the point. -6.48. In the year 2003, what is the difference between the Persistence rate to the last grade of primary education (%) in Small states and Persistence rate to the last grade of primary education (%) in Ecuador?
Give a very brief answer. -0.24. In the year 2003, what is the difference between the Persistence rate to the last grade of primary education (%) of Small states and Persistence rate to the last grade of primary education (%) of Mali?
Provide a short and direct response. -0.53. In the year 2003, what is the difference between the Persistence rate to the last grade of primary education (%) of Small states and Persistence rate to the last grade of primary education (%) of Peru?
Keep it short and to the point. -10.7. In the year 2003, what is the difference between the Persistence rate to the last grade of primary education (%) of Ecuador and Persistence rate to the last grade of primary education (%) of Mali?
Provide a succinct answer. -0.28. In the year 2003, what is the difference between the Persistence rate to the last grade of primary education (%) of Ecuador and Persistence rate to the last grade of primary education (%) of Peru?
Offer a very short reply. -10.46. In the year 2003, what is the difference between the Persistence rate to the last grade of primary education (%) in Mali and Persistence rate to the last grade of primary education (%) in Peru?
Offer a terse response. -10.17. In the year 2004, what is the difference between the Persistence rate to the last grade of primary education (%) in Small states and Persistence rate to the last grade of primary education (%) in Ecuador?
Provide a succinct answer. -3.87. In the year 2004, what is the difference between the Persistence rate to the last grade of primary education (%) in Small states and Persistence rate to the last grade of primary education (%) in Mali?
Your response must be concise. -1.95. In the year 2004, what is the difference between the Persistence rate to the last grade of primary education (%) in Small states and Persistence rate to the last grade of primary education (%) in Peru?
Give a very brief answer. -12.16. In the year 2004, what is the difference between the Persistence rate to the last grade of primary education (%) of Ecuador and Persistence rate to the last grade of primary education (%) of Mali?
Provide a succinct answer. 1.92. In the year 2004, what is the difference between the Persistence rate to the last grade of primary education (%) in Ecuador and Persistence rate to the last grade of primary education (%) in Peru?
Provide a succinct answer. -8.29. In the year 2004, what is the difference between the Persistence rate to the last grade of primary education (%) in Mali and Persistence rate to the last grade of primary education (%) in Peru?
Your answer should be very brief. -10.21. In the year 2005, what is the difference between the Persistence rate to the last grade of primary education (%) of Small states and Persistence rate to the last grade of primary education (%) of Ecuador?
Offer a very short reply. -3.03. In the year 2005, what is the difference between the Persistence rate to the last grade of primary education (%) of Small states and Persistence rate to the last grade of primary education (%) of Mali?
Your answer should be very brief. 2.53. In the year 2005, what is the difference between the Persistence rate to the last grade of primary education (%) of Small states and Persistence rate to the last grade of primary education (%) of Peru?
Provide a succinct answer. -10.72. In the year 2005, what is the difference between the Persistence rate to the last grade of primary education (%) in Ecuador and Persistence rate to the last grade of primary education (%) in Mali?
Keep it short and to the point. 5.57. In the year 2005, what is the difference between the Persistence rate to the last grade of primary education (%) of Ecuador and Persistence rate to the last grade of primary education (%) of Peru?
Offer a terse response. -7.69. In the year 2005, what is the difference between the Persistence rate to the last grade of primary education (%) of Mali and Persistence rate to the last grade of primary education (%) of Peru?
Your answer should be compact. -13.26. In the year 2010, what is the difference between the Persistence rate to the last grade of primary education (%) in Small states and Persistence rate to the last grade of primary education (%) in Ecuador?
Make the answer very short. -20.64. In the year 2010, what is the difference between the Persistence rate to the last grade of primary education (%) in Small states and Persistence rate to the last grade of primary education (%) in Mali?
Give a very brief answer. -1.32. In the year 2010, what is the difference between the Persistence rate to the last grade of primary education (%) in Small states and Persistence rate to the last grade of primary education (%) in Peru?
Offer a terse response. -8.43. In the year 2010, what is the difference between the Persistence rate to the last grade of primary education (%) of Ecuador and Persistence rate to the last grade of primary education (%) of Mali?
Ensure brevity in your answer.  19.32. In the year 2010, what is the difference between the Persistence rate to the last grade of primary education (%) of Ecuador and Persistence rate to the last grade of primary education (%) of Peru?
Keep it short and to the point. 12.21. In the year 2010, what is the difference between the Persistence rate to the last grade of primary education (%) in Mali and Persistence rate to the last grade of primary education (%) in Peru?
Your answer should be very brief. -7.11. What is the ratio of the Persistence rate to the last grade of primary education (%) of Small states in 1979 to that in 1999?
Your response must be concise. 0.89. What is the ratio of the Persistence rate to the last grade of primary education (%) in Ecuador in 1979 to that in 1999?
Keep it short and to the point. 0.63. What is the ratio of the Persistence rate to the last grade of primary education (%) in Mali in 1979 to that in 1999?
Make the answer very short. 0.63. What is the ratio of the Persistence rate to the last grade of primary education (%) of Peru in 1979 to that in 1999?
Provide a succinct answer. 0.71. What is the ratio of the Persistence rate to the last grade of primary education (%) of Small states in 1979 to that in 2001?
Provide a succinct answer. 0.89. What is the ratio of the Persistence rate to the last grade of primary education (%) in Ecuador in 1979 to that in 2001?
Your answer should be compact. 0.62. What is the ratio of the Persistence rate to the last grade of primary education (%) of Mali in 1979 to that in 2001?
Your answer should be compact. 0.55. What is the ratio of the Persistence rate to the last grade of primary education (%) of Peru in 1979 to that in 2001?
Provide a succinct answer. 0.75. What is the ratio of the Persistence rate to the last grade of primary education (%) in Small states in 1979 to that in 2003?
Your answer should be compact. 0.87. What is the ratio of the Persistence rate to the last grade of primary education (%) of Ecuador in 1979 to that in 2003?
Your answer should be very brief. 0.65. What is the ratio of the Persistence rate to the last grade of primary education (%) of Mali in 1979 to that in 2003?
Your answer should be very brief. 0.53. What is the ratio of the Persistence rate to the last grade of primary education (%) of Peru in 1979 to that in 2003?
Your answer should be very brief. 0.69. What is the ratio of the Persistence rate to the last grade of primary education (%) of Small states in 1979 to that in 2004?
Ensure brevity in your answer.  0.87. What is the ratio of the Persistence rate to the last grade of primary education (%) of Ecuador in 1979 to that in 2004?
Your answer should be very brief. 0.62. What is the ratio of the Persistence rate to the last grade of primary education (%) of Mali in 1979 to that in 2004?
Keep it short and to the point. 0.52. What is the ratio of the Persistence rate to the last grade of primary education (%) in Peru in 1979 to that in 2004?
Provide a succinct answer. 0.68. What is the ratio of the Persistence rate to the last grade of primary education (%) in Small states in 1979 to that in 2005?
Your answer should be compact. 0.87. What is the ratio of the Persistence rate to the last grade of primary education (%) of Ecuador in 1979 to that in 2005?
Your answer should be compact. 0.62. What is the ratio of the Persistence rate to the last grade of primary education (%) in Mali in 1979 to that in 2005?
Your response must be concise. 0.55. What is the ratio of the Persistence rate to the last grade of primary education (%) of Peru in 1979 to that in 2005?
Ensure brevity in your answer.  0.69. What is the ratio of the Persistence rate to the last grade of primary education (%) of Small states in 1979 to that in 2010?
Offer a terse response. 0.88. What is the ratio of the Persistence rate to the last grade of primary education (%) in Ecuador in 1979 to that in 2010?
Ensure brevity in your answer.  0.51. What is the ratio of the Persistence rate to the last grade of primary education (%) in Mali in 1979 to that in 2010?
Your response must be concise. 0.53. What is the ratio of the Persistence rate to the last grade of primary education (%) of Peru in 1979 to that in 2010?
Ensure brevity in your answer.  0.72. What is the ratio of the Persistence rate to the last grade of primary education (%) in Small states in 1999 to that in 2001?
Ensure brevity in your answer.  0.99. What is the ratio of the Persistence rate to the last grade of primary education (%) of Ecuador in 1999 to that in 2001?
Provide a succinct answer. 0.97. What is the ratio of the Persistence rate to the last grade of primary education (%) in Mali in 1999 to that in 2001?
Your response must be concise. 0.88. What is the ratio of the Persistence rate to the last grade of primary education (%) in Peru in 1999 to that in 2001?
Your answer should be very brief. 1.06. What is the ratio of the Persistence rate to the last grade of primary education (%) in Small states in 1999 to that in 2003?
Keep it short and to the point. 0.97. What is the ratio of the Persistence rate to the last grade of primary education (%) in Ecuador in 1999 to that in 2003?
Your response must be concise. 1.02. What is the ratio of the Persistence rate to the last grade of primary education (%) in Mali in 1999 to that in 2003?
Make the answer very short. 0.84. What is the ratio of the Persistence rate to the last grade of primary education (%) in Peru in 1999 to that in 2003?
Your answer should be compact. 0.98. What is the ratio of the Persistence rate to the last grade of primary education (%) of Small states in 1999 to that in 2004?
Give a very brief answer. 0.98. What is the ratio of the Persistence rate to the last grade of primary education (%) of Ecuador in 1999 to that in 2004?
Keep it short and to the point. 0.98. What is the ratio of the Persistence rate to the last grade of primary education (%) in Mali in 1999 to that in 2004?
Provide a short and direct response. 0.83. What is the ratio of the Persistence rate to the last grade of primary education (%) in Peru in 1999 to that in 2004?
Your answer should be compact. 0.96. What is the ratio of the Persistence rate to the last grade of primary education (%) of Small states in 1999 to that in 2005?
Provide a short and direct response. 0.97. What is the ratio of the Persistence rate to the last grade of primary education (%) of Ecuador in 1999 to that in 2005?
Make the answer very short. 0.98. What is the ratio of the Persistence rate to the last grade of primary education (%) of Mali in 1999 to that in 2005?
Your response must be concise. 0.88. What is the ratio of the Persistence rate to the last grade of primary education (%) of Peru in 1999 to that in 2005?
Provide a short and direct response. 0.97. What is the ratio of the Persistence rate to the last grade of primary education (%) of Small states in 1999 to that in 2010?
Your response must be concise. 0.98. What is the ratio of the Persistence rate to the last grade of primary education (%) of Ecuador in 1999 to that in 2010?
Your response must be concise. 0.81. What is the ratio of the Persistence rate to the last grade of primary education (%) of Mali in 1999 to that in 2010?
Offer a very short reply. 0.84. What is the ratio of the Persistence rate to the last grade of primary education (%) of Peru in 1999 to that in 2010?
Make the answer very short. 1.01. What is the ratio of the Persistence rate to the last grade of primary education (%) of Small states in 2001 to that in 2003?
Your answer should be compact. 0.98. What is the ratio of the Persistence rate to the last grade of primary education (%) in Ecuador in 2001 to that in 2003?
Your answer should be compact. 1.05. What is the ratio of the Persistence rate to the last grade of primary education (%) in Mali in 2001 to that in 2003?
Your answer should be compact. 0.96. What is the ratio of the Persistence rate to the last grade of primary education (%) in Peru in 2001 to that in 2003?
Your answer should be very brief. 0.92. What is the ratio of the Persistence rate to the last grade of primary education (%) of Small states in 2001 to that in 2004?
Keep it short and to the point. 0.98. What is the ratio of the Persistence rate to the last grade of primary education (%) in Mali in 2001 to that in 2004?
Your answer should be very brief. 0.94. What is the ratio of the Persistence rate to the last grade of primary education (%) of Peru in 2001 to that in 2004?
Offer a terse response. 0.9. What is the ratio of the Persistence rate to the last grade of primary education (%) of Small states in 2001 to that in 2005?
Give a very brief answer. 0.98. What is the ratio of the Persistence rate to the last grade of primary education (%) of Ecuador in 2001 to that in 2005?
Make the answer very short. 1.01. What is the ratio of the Persistence rate to the last grade of primary education (%) in Peru in 2001 to that in 2005?
Ensure brevity in your answer.  0.91. What is the ratio of the Persistence rate to the last grade of primary education (%) in Ecuador in 2001 to that in 2010?
Give a very brief answer. 0.83. What is the ratio of the Persistence rate to the last grade of primary education (%) in Mali in 2001 to that in 2010?
Your answer should be compact. 0.96. What is the ratio of the Persistence rate to the last grade of primary education (%) in Peru in 2001 to that in 2010?
Your answer should be very brief. 0.95. What is the ratio of the Persistence rate to the last grade of primary education (%) in Small states in 2003 to that in 2004?
Your answer should be compact. 1. What is the ratio of the Persistence rate to the last grade of primary education (%) in Ecuador in 2003 to that in 2004?
Give a very brief answer. 0.96. What is the ratio of the Persistence rate to the last grade of primary education (%) in Mali in 2003 to that in 2004?
Provide a short and direct response. 0.98. What is the ratio of the Persistence rate to the last grade of primary education (%) of Peru in 2003 to that in 2004?
Your response must be concise. 0.99. What is the ratio of the Persistence rate to the last grade of primary education (%) of Small states in 2003 to that in 2005?
Make the answer very short. 1. What is the ratio of the Persistence rate to the last grade of primary education (%) of Ecuador in 2003 to that in 2005?
Make the answer very short. 0.96. What is the ratio of the Persistence rate to the last grade of primary education (%) in Mali in 2003 to that in 2005?
Keep it short and to the point. 1.04. What is the ratio of the Persistence rate to the last grade of primary education (%) of Ecuador in 2003 to that in 2010?
Keep it short and to the point. 0.79. What is the ratio of the Persistence rate to the last grade of primary education (%) in Peru in 2003 to that in 2010?
Keep it short and to the point. 1.04. What is the ratio of the Persistence rate to the last grade of primary education (%) of Ecuador in 2004 to that in 2005?
Give a very brief answer. 1.01. What is the ratio of the Persistence rate to the last grade of primary education (%) in Mali in 2004 to that in 2005?
Keep it short and to the point. 1.06. What is the ratio of the Persistence rate to the last grade of primary education (%) in Peru in 2004 to that in 2005?
Make the answer very short. 1.01. What is the ratio of the Persistence rate to the last grade of primary education (%) in Small states in 2004 to that in 2010?
Make the answer very short. 1.01. What is the ratio of the Persistence rate to the last grade of primary education (%) in Ecuador in 2004 to that in 2010?
Ensure brevity in your answer.  0.83. What is the ratio of the Persistence rate to the last grade of primary education (%) in Mali in 2004 to that in 2010?
Provide a short and direct response. 1.02. What is the ratio of the Persistence rate to the last grade of primary education (%) in Peru in 2004 to that in 2010?
Offer a very short reply. 1.05. What is the ratio of the Persistence rate to the last grade of primary education (%) in Small states in 2005 to that in 2010?
Your response must be concise. 1.01. What is the ratio of the Persistence rate to the last grade of primary education (%) in Ecuador in 2005 to that in 2010?
Ensure brevity in your answer.  0.82. What is the ratio of the Persistence rate to the last grade of primary education (%) of Mali in 2005 to that in 2010?
Your answer should be very brief. 0.96. What is the ratio of the Persistence rate to the last grade of primary education (%) in Peru in 2005 to that in 2010?
Offer a terse response. 1.04. What is the difference between the highest and the second highest Persistence rate to the last grade of primary education (%) in Small states?
Provide a short and direct response. 0.19. What is the difference between the highest and the second highest Persistence rate to the last grade of primary education (%) of Ecuador?
Your answer should be very brief. 16.1. What is the difference between the highest and the second highest Persistence rate to the last grade of primary education (%) of Mali?
Offer a terse response. 1.16. What is the difference between the highest and the second highest Persistence rate to the last grade of primary education (%) of Peru?
Provide a short and direct response. 1.04. What is the difference between the highest and the lowest Persistence rate to the last grade of primary education (%) of Small states?
Offer a terse response. 9.84. What is the difference between the highest and the lowest Persistence rate to the last grade of primary education (%) in Ecuador?
Provide a short and direct response. 45.57. What is the difference between the highest and the lowest Persistence rate to the last grade of primary education (%) in Mali?
Give a very brief answer. 35.85. What is the difference between the highest and the lowest Persistence rate to the last grade of primary education (%) in Peru?
Your answer should be very brief. 27.02. 